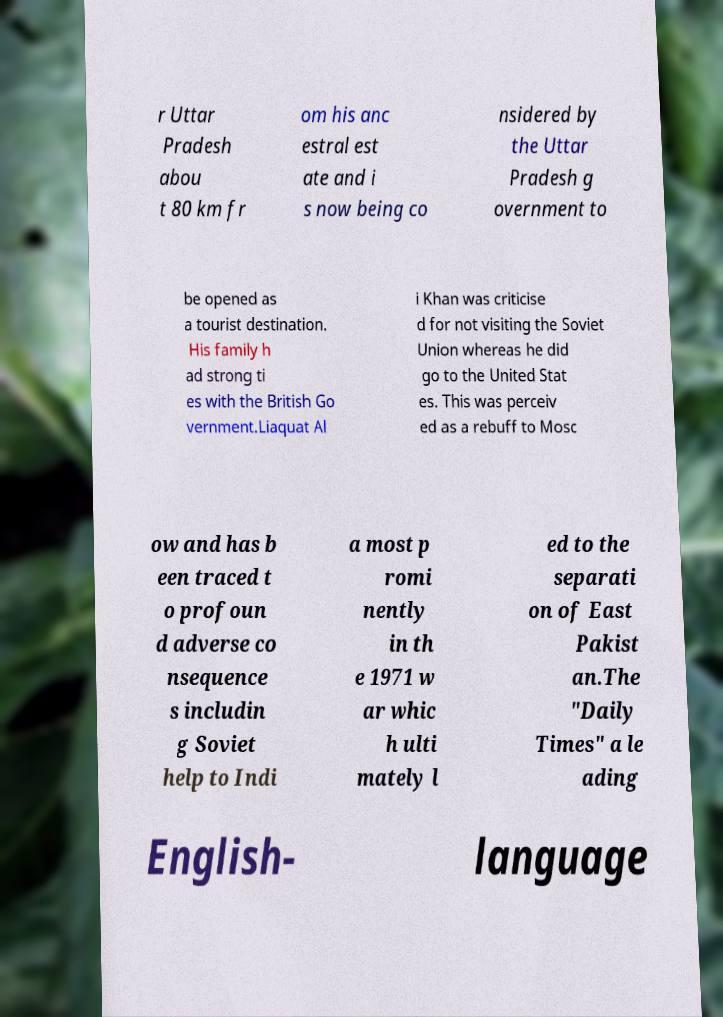Can you read and provide the text displayed in the image?This photo seems to have some interesting text. Can you extract and type it out for me? r Uttar Pradesh abou t 80 km fr om his anc estral est ate and i s now being co nsidered by the Uttar Pradesh g overnment to be opened as a tourist destination. His family h ad strong ti es with the British Go vernment.Liaquat Al i Khan was criticise d for not visiting the Soviet Union whereas he did go to the United Stat es. This was perceiv ed as a rebuff to Mosc ow and has b een traced t o profoun d adverse co nsequence s includin g Soviet help to Indi a most p romi nently in th e 1971 w ar whic h ulti mately l ed to the separati on of East Pakist an.The "Daily Times" a le ading English- language 